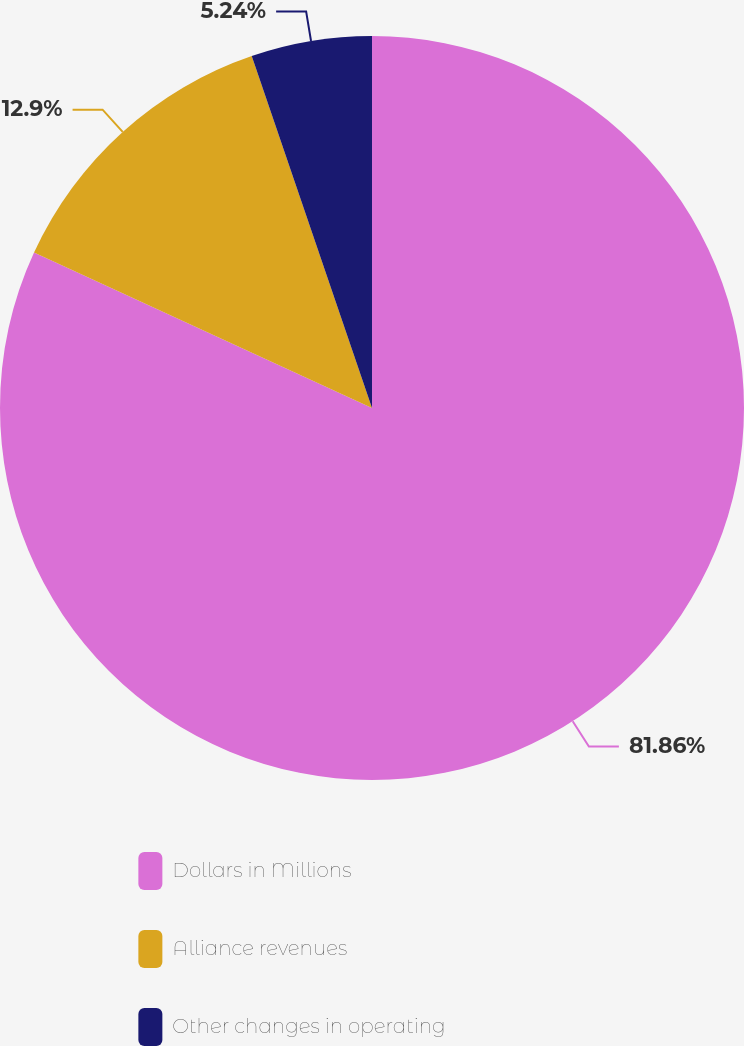Convert chart to OTSL. <chart><loc_0><loc_0><loc_500><loc_500><pie_chart><fcel>Dollars in Millions<fcel>Alliance revenues<fcel>Other changes in operating<nl><fcel>81.86%<fcel>12.9%<fcel>5.24%<nl></chart> 